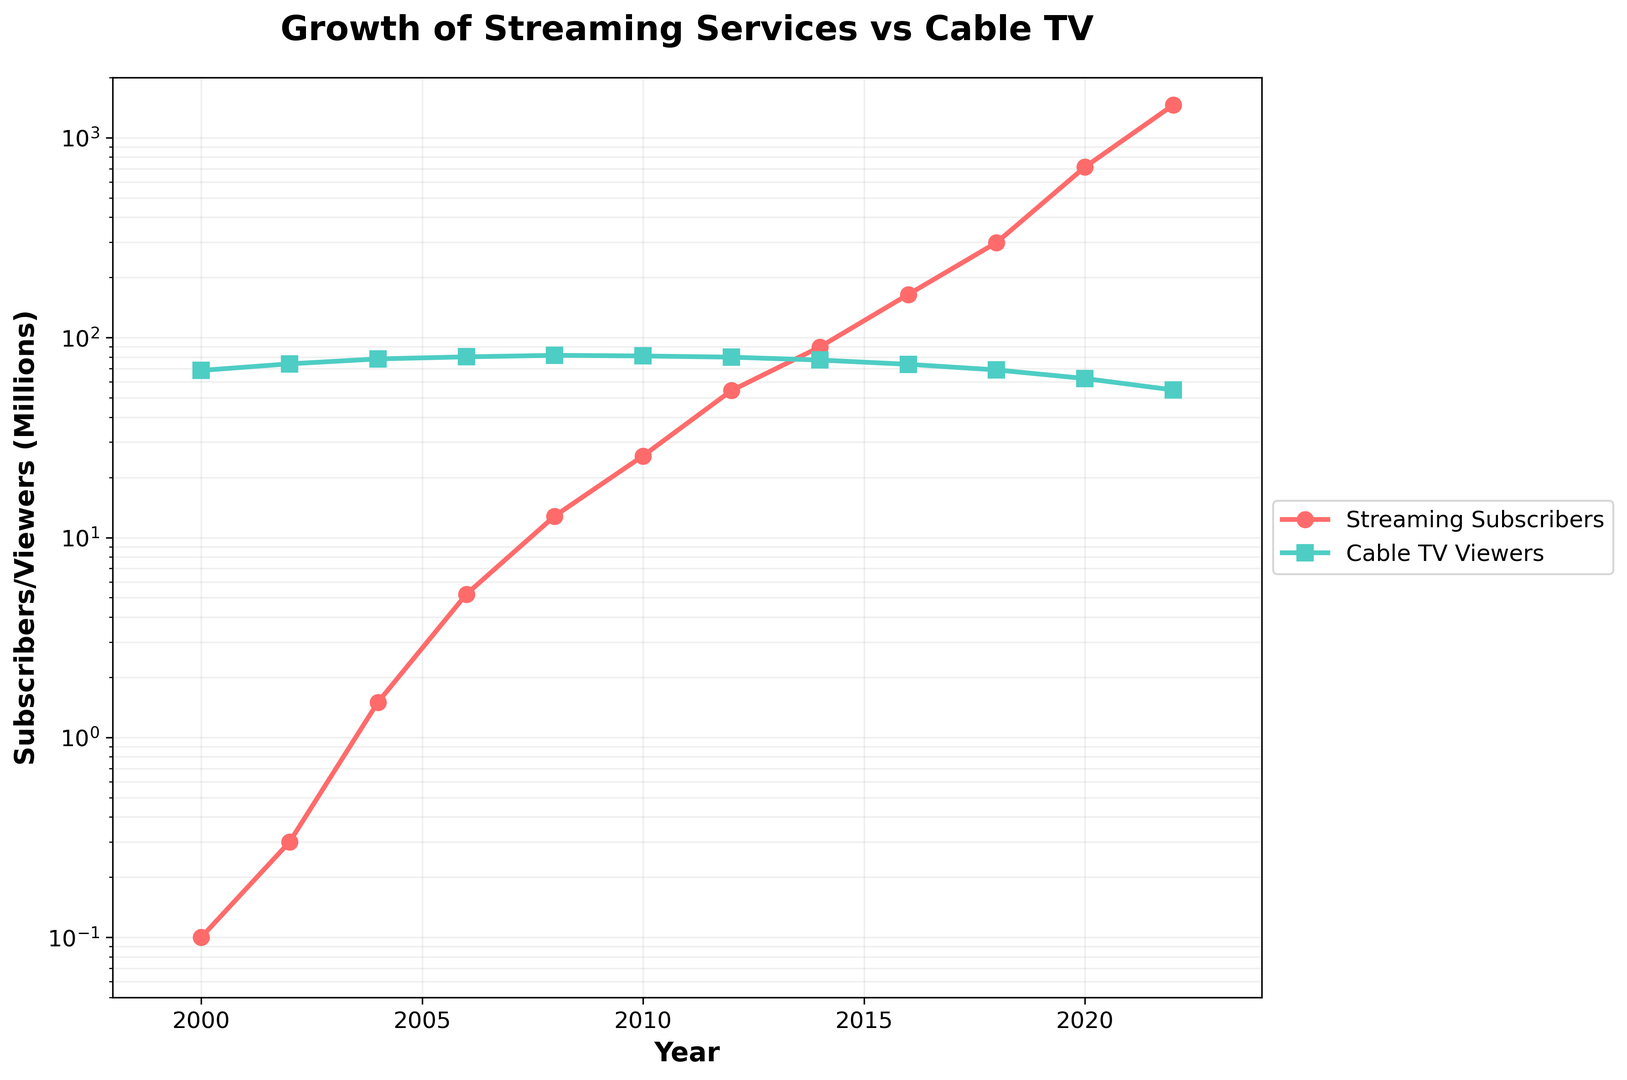What year did streaming subscribers surpass cable TV viewers? By inspecting the chart, observe the point where the line representing streaming subscribers crosses above the line representing cable TV viewers. This occurs around the year 2018.
Answer: 2018 In 2022, how many more millions of streaming subscribers were there compared to cable TV viewers? In 2022, streaming subscribers were approximately 1456.8 million, and cable TV viewers were approximately 54.7 million. The difference is 1456.8 - 54.7 = 1402.1 million.
Answer: 1402.1 million Between 2000 and 2020, during which period did streaming subscribers grow the most rapidly? The chart shows the steepest incline in the streaming subscribers' trajectory between 2016 and 2020, indicating the most rapid growth during this period.
Answer: 2016-2020 What is the ratio of streaming subscribers to cable TV viewers in 2016? In 2016, there were approximately 164.2 million streaming subscribers and 73.5 million cable TV viewers. The ratio is 164.2 / 73.5 ≈ 2.23.
Answer: 2.23 Compare the number of streaming subscribers in 2010 to the number of cable TV viewers in 2010. Which is higher? In 2010, streaming subscribers accounted for approximately 25.6 million, whereas cable TV viewers were approximately 80.9 million. Therefore, cable TV viewers were higher.
Answer: Cable TV viewers Which year saw the least difference between the number of streaming subscribers and cable TV viewers? By examining the distances between the two lines in the chart, the smallest gap appears to be in the year 2018, where both lines are closer together.
Answer: 2018 How did the number of cable TV viewers change from 2000 to 2022? In 2000, the number of cable TV viewers was approximately 68.5 million. By 2022, this number had decreased to approximately 54.7 million.
Answer: Decreased What trend can be observed in the number of cable TV viewers over the two decades? The line representing cable TV viewers shows a general downward trend from 2000 to 2022.
Answer: Downward trend Calculate the average annual growth rate of streaming subscribers from 2000 to 2022. The streaming subscribers grew from 0.1 million in 2000 to 1456.8 million in 2022. The average annual growth rate can be approximated using the formula [(Final Value / Initial Value)^(1/Number of Years)] - 1. Plugging in the values: [(1456.8 / 0.1)^(1/22)] - 1 ≈ 0.701 or 70.1%.
Answer: 70.1% 